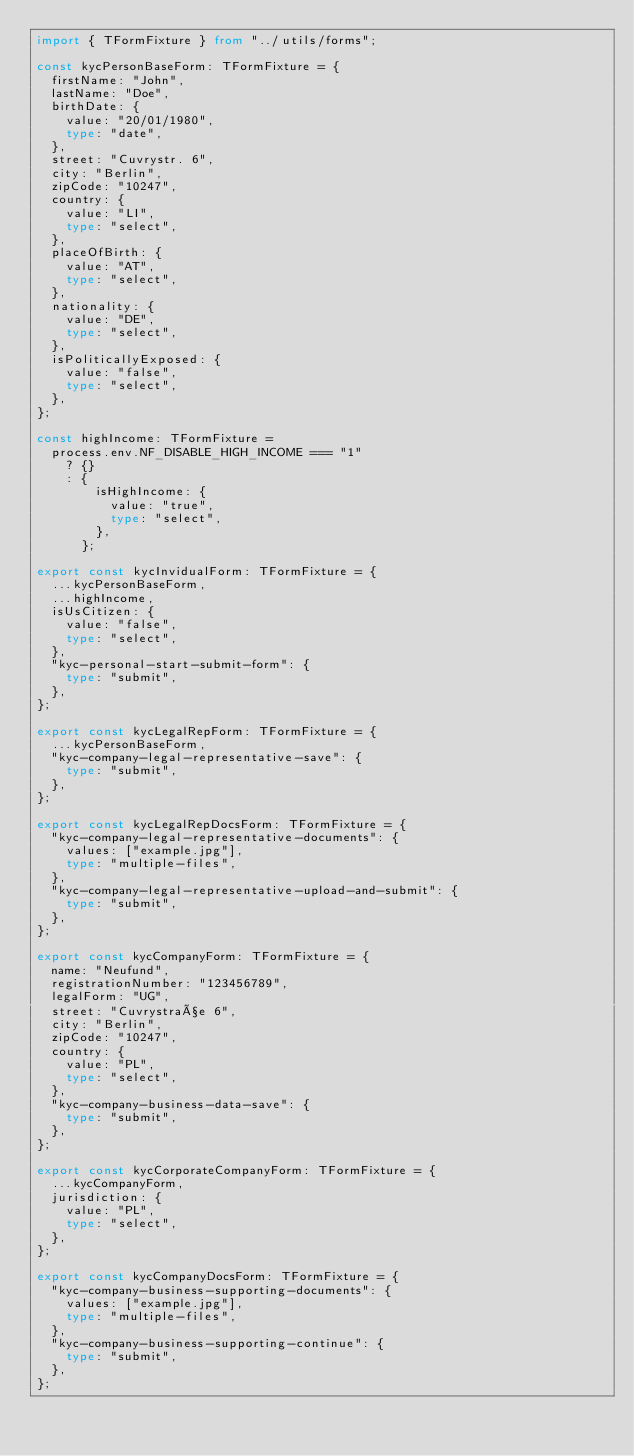<code> <loc_0><loc_0><loc_500><loc_500><_TypeScript_>import { TFormFixture } from "../utils/forms";

const kycPersonBaseForm: TFormFixture = {
  firstName: "John",
  lastName: "Doe",
  birthDate: {
    value: "20/01/1980",
    type: "date",
  },
  street: "Cuvrystr. 6",
  city: "Berlin",
  zipCode: "10247",
  country: {
    value: "LI",
    type: "select",
  },
  placeOfBirth: {
    value: "AT",
    type: "select",
  },
  nationality: {
    value: "DE",
    type: "select",
  },
  isPoliticallyExposed: {
    value: "false",
    type: "select",
  },
};

const highIncome: TFormFixture =
  process.env.NF_DISABLE_HIGH_INCOME === "1"
    ? {}
    : {
        isHighIncome: {
          value: "true",
          type: "select",
        },
      };

export const kycInvidualForm: TFormFixture = {
  ...kycPersonBaseForm,
  ...highIncome,
  isUsCitizen: {
    value: "false",
    type: "select",
  },
  "kyc-personal-start-submit-form": {
    type: "submit",
  },
};

export const kycLegalRepForm: TFormFixture = {
  ...kycPersonBaseForm,
  "kyc-company-legal-representative-save": {
    type: "submit",
  },
};

export const kycLegalRepDocsForm: TFormFixture = {
  "kyc-company-legal-representative-documents": {
    values: ["example.jpg"],
    type: "multiple-files",
  },
  "kyc-company-legal-representative-upload-and-submit": {
    type: "submit",
  },
};

export const kycCompanyForm: TFormFixture = {
  name: "Neufund",
  registrationNumber: "123456789",
  legalForm: "UG",
  street: "Cuvrystraße 6",
  city: "Berlin",
  zipCode: "10247",
  country: {
    value: "PL",
    type: "select",
  },
  "kyc-company-business-data-save": {
    type: "submit",
  },
};

export const kycCorporateCompanyForm: TFormFixture = {
  ...kycCompanyForm,
  jurisdiction: {
    value: "PL",
    type: "select",
  },
};

export const kycCompanyDocsForm: TFormFixture = {
  "kyc-company-business-supporting-documents": {
    values: ["example.jpg"],
    type: "multiple-files",
  },
  "kyc-company-business-supporting-continue": {
    type: "submit",
  },
};
</code> 